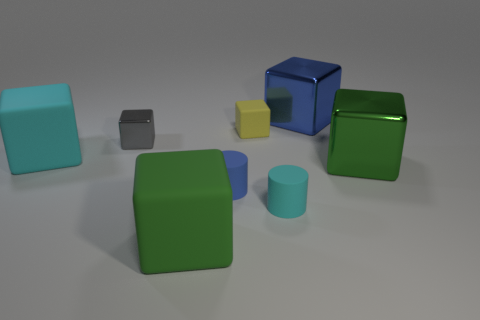What is the color of the other large metal thing that is the same shape as the blue metal thing? The other large object that shares the same cube shape as the blue metal one is colored in a glossy green. It stands out with its reflective surface similar to the blue cube, and it's positioned diagonally opposite to the blue one on the image. 